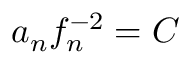Convert formula to latex. <formula><loc_0><loc_0><loc_500><loc_500>a _ { n } f _ { n } ^ { - 2 } = C</formula> 